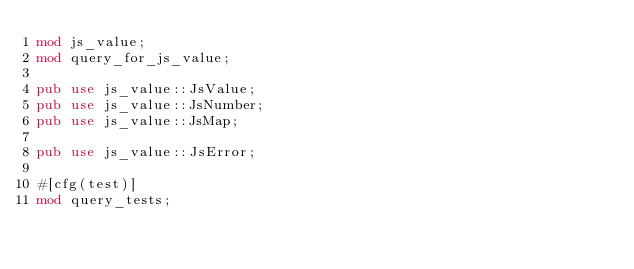<code> <loc_0><loc_0><loc_500><loc_500><_Rust_>mod js_value;
mod query_for_js_value;

pub use js_value::JsValue;
pub use js_value::JsNumber;
pub use js_value::JsMap;

pub use js_value::JsError;

#[cfg(test)]
mod query_tests;
</code> 